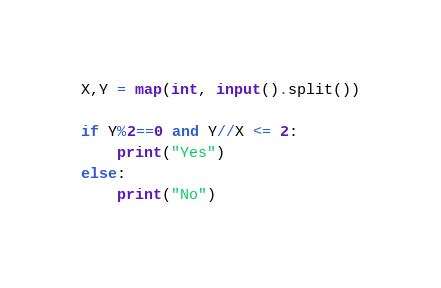<code> <loc_0><loc_0><loc_500><loc_500><_Python_>X,Y = map(int, input().split())

if Y%2==0 and Y//X <= 2: 
    print("Yes")
else: 
    print("No")
</code> 